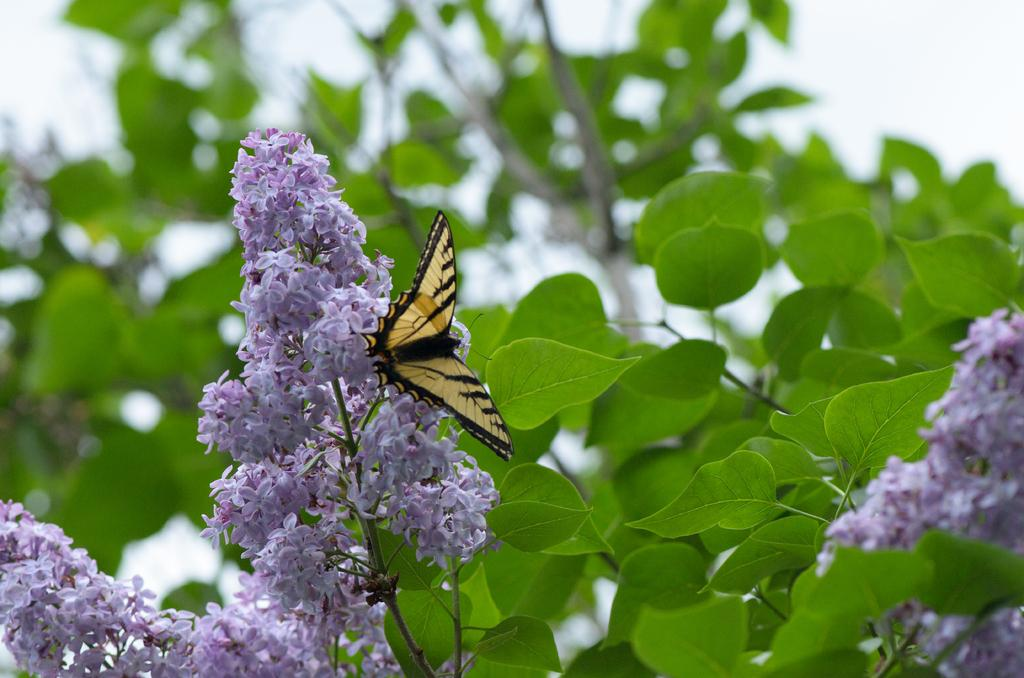What type of flowers can be seen in the image? There are purple color flowers in the image. What other plant elements are present in the image? There are green color leaves in the image. What can be seen in the background of the image? The sky is visible in the image. What insect is present in the image? There is a yellow and black color butterfly in the image. What type of store can be seen in the image? There is no store present in the image; it features flowers, leaves, the sky, and a butterfly. 